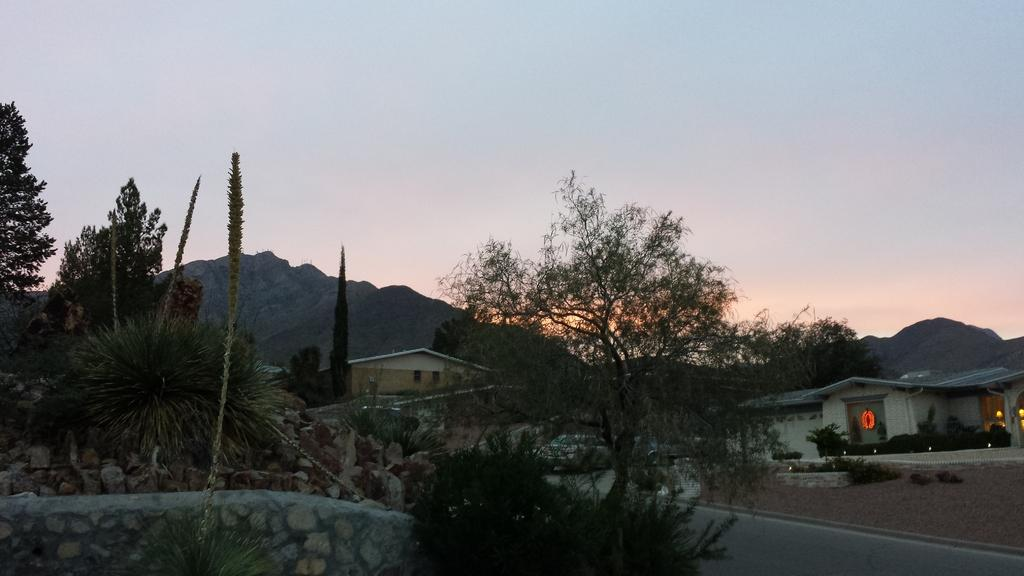What type of natural elements can be seen in the image? There are many trees and plants in the image. What man-made elements can be seen in the image? There are stones, a road, and houses in the image. What can be seen in the background of the image? There are hills and the sky visible in the background of the image. Can you tell me how many horses are present in the image? There are no horses present in the image. Is it possible to believe that the stones in the image are actually trick candies? No, the stones in the image are not trick candies; they are actual stones. 